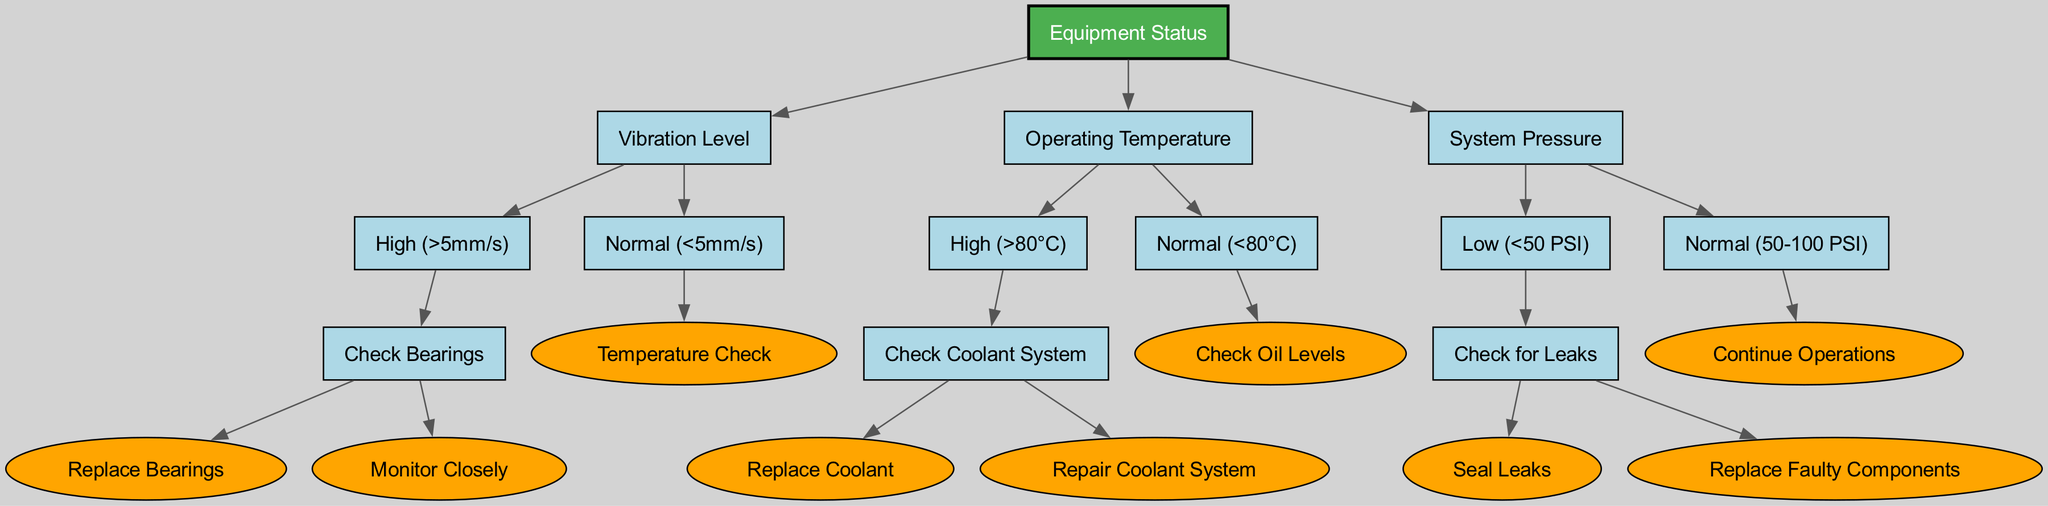What is the root node of the decision tree? The root node of the decision tree is "Equipment Status." This is where the decision-making process begins and represents the overall status being assessed.
Answer: Equipment Status How many main branches are there from the root node? From the root node, there are three main branches that represent different decision criteria: Vibration Level, Operating Temperature, and System Pressure.
Answer: 3 What action should be taken if the vibration level is high? If the vibration level is high (greater than 5mm/s), the next action in the decision tree is to "Check Bearings." This indicates a need for further inspection regarding the bearings.
Answer: Check Bearings If the operating temperature is normal, what is the next check? When the operating temperature is normal (less than 80°C), the next check in the decision tree is to "Check Oil Levels." This action is essential for maintaining optimal functioning of the equipment.
Answer: Check Oil Levels What does the tree suggest if the system pressure is normal? If the system pressure is in the normal range (between 50-100 PSI), the decision tree indicates to "Continue Operations," suggesting that no immediate action is needed.
Answer: Continue Operations What are the consequences of low pressure (<50 PSI) based on the diagram? In the case of low pressure (less than 50 PSI), the decision tree directs to "Check for Leaks." This indicates the necessity for further investigation to locate any potential leakage issues.
Answer: Check for Leaks How many different statuses are associated with vibration level? The vibration level has two statuses associated with it: "High" (greater than 5mm/s) and "Normal" (less than 5mm/s). This bifurcation represents the two possible conditions that influence subsequent actions.
Answer: 2 What are the actions required if the temperature is high (>80°C)? If the temperature exceeds 80°C, the decision tree suggests checking the coolant system. This step can lead to two potential actions: "Replace Coolant" or "Repair Coolant System."
Answer: Check Coolant System In case of high vibration (>5mm/s), what are the follow-up actions available? When the vibration is high (greater than 5mm/s), the follow-up actions available are "Replace Bearings" or "Monitor Closely." This highlights the possible approaches based on the first diagnostic step.
Answer: Replace Bearings or Monitor Closely 